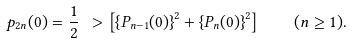Convert formula to latex. <formula><loc_0><loc_0><loc_500><loc_500>p _ { 2 n } ( 0 ) = \frac { 1 } { 2 } \ > \left [ \left \{ P _ { n - 1 } ( 0 ) \right \} ^ { 2 } + \left \{ P _ { n } ( 0 ) \right \} ^ { 2 } \right ] \quad ( n \geq 1 ) .</formula> 